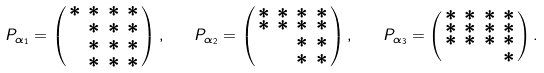Convert formula to latex. <formula><loc_0><loc_0><loc_500><loc_500>P _ { \alpha _ { 1 } } = \left ( \begin{smallmatrix} * & * & * & * \\ 0 & * & * & * \\ 0 & * & * & * \\ 0 & * & * & * \end{smallmatrix} \right ) , \quad P _ { \alpha _ { 2 } } = \left ( \begin{smallmatrix} * & * & * & * \\ * & * & * & * \\ 0 & 0 & * & * \\ 0 & 0 & * & * \end{smallmatrix} \right ) , \quad P _ { \alpha _ { 3 } } = \left ( \begin{smallmatrix} * & * & * & * \\ * & * & * & * \\ * & * & * & * \\ 0 & 0 & 0 & * \end{smallmatrix} \right ) .</formula> 